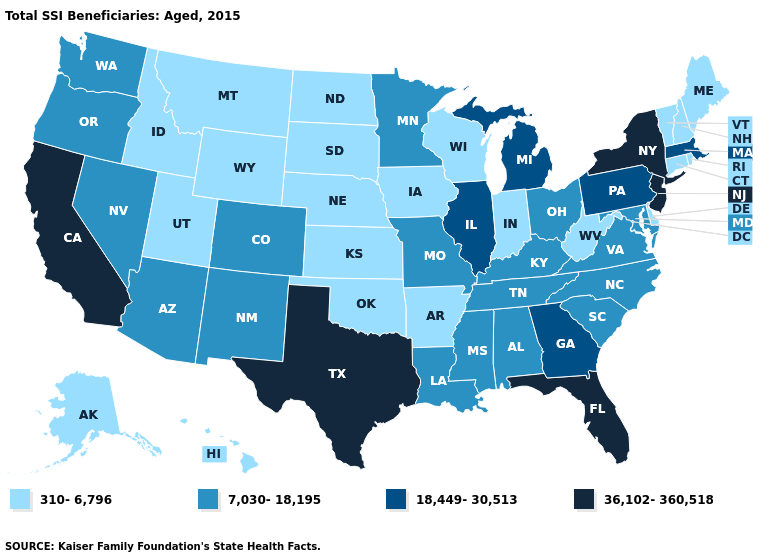What is the value of Pennsylvania?
Write a very short answer. 18,449-30,513. What is the highest value in the USA?
Keep it brief. 36,102-360,518. What is the value of Arkansas?
Answer briefly. 310-6,796. Which states have the highest value in the USA?
Be succinct. California, Florida, New Jersey, New York, Texas. Name the states that have a value in the range 310-6,796?
Keep it brief. Alaska, Arkansas, Connecticut, Delaware, Hawaii, Idaho, Indiana, Iowa, Kansas, Maine, Montana, Nebraska, New Hampshire, North Dakota, Oklahoma, Rhode Island, South Dakota, Utah, Vermont, West Virginia, Wisconsin, Wyoming. Among the states that border New Mexico , which have the highest value?
Short answer required. Texas. Name the states that have a value in the range 36,102-360,518?
Short answer required. California, Florida, New Jersey, New York, Texas. Name the states that have a value in the range 310-6,796?
Answer briefly. Alaska, Arkansas, Connecticut, Delaware, Hawaii, Idaho, Indiana, Iowa, Kansas, Maine, Montana, Nebraska, New Hampshire, North Dakota, Oklahoma, Rhode Island, South Dakota, Utah, Vermont, West Virginia, Wisconsin, Wyoming. Name the states that have a value in the range 18,449-30,513?
Short answer required. Georgia, Illinois, Massachusetts, Michigan, Pennsylvania. What is the lowest value in the USA?
Write a very short answer. 310-6,796. What is the highest value in the West ?
Quick response, please. 36,102-360,518. What is the value of Virginia?
Be succinct. 7,030-18,195. How many symbols are there in the legend?
Give a very brief answer. 4. Does the first symbol in the legend represent the smallest category?
Short answer required. Yes. 